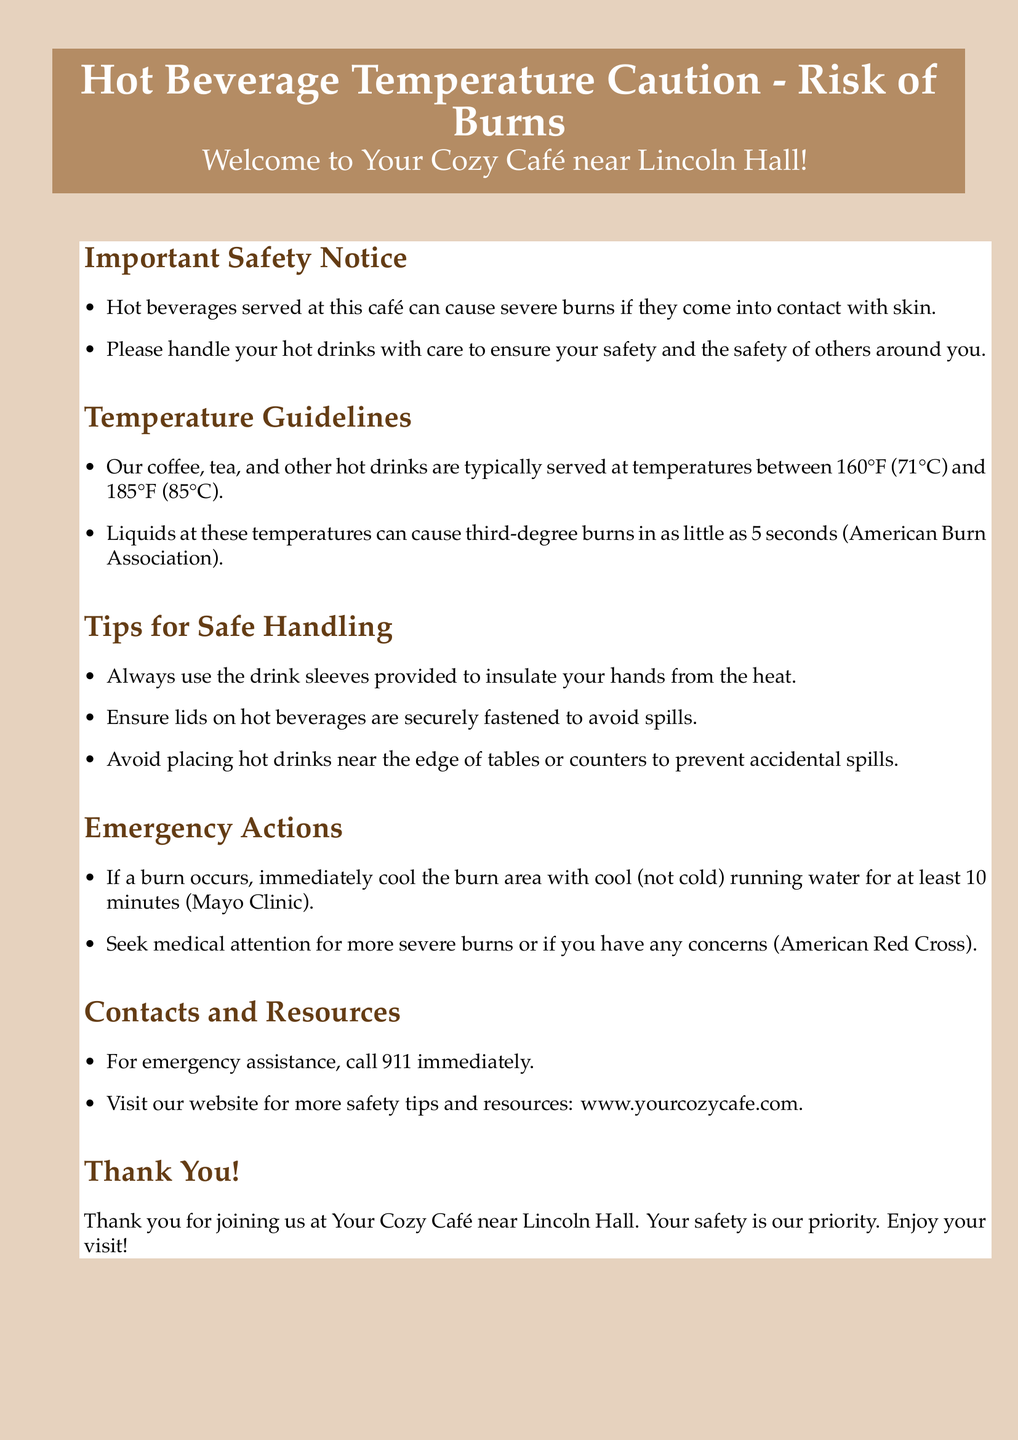What is the maximum temperature for hot beverages? The maximum temperature for hot beverages is typically 185°F (85°C).
Answer: 185°F (85°C) What is the recommended cooling time for a burn? The document states to cool the burn area with running water for at least 10 minutes.
Answer: 10 minutes What should you do if a burn occurs? You should immediately cool the burn area with cool running water.
Answer: Cool with running water What is the main purpose of drink sleeves? The drink sleeves are provided to insulate your hands from the heat.
Answer: Insulate hands from heat How long can it take for hot liquids to cause third-degree burns? Liquids at the stated temperatures can cause third-degree burns in as little as 5 seconds.
Answer: 5 seconds What kind of medical assistance should you seek for severe burns? You should seek medical attention for more severe burns or if you have any concerns.
Answer: Medical attention What phone number should you call for emergency assistance? The emergency assistance phone number provided in the document is 911.
Answer: 911 What organization is referenced for burn information? The American Burn Association is referenced for burn information related to hot beverages.
Answer: American Burn Association 